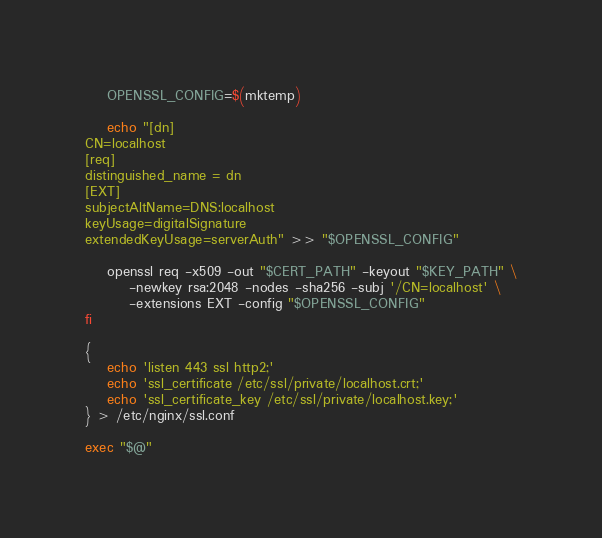<code> <loc_0><loc_0><loc_500><loc_500><_Bash_>    OPENSSL_CONFIG=$(mktemp)

    echo "[dn]
CN=localhost
[req]
distinguished_name = dn
[EXT]
subjectAltName=DNS:localhost
keyUsage=digitalSignature
extendedKeyUsage=serverAuth" >> "$OPENSSL_CONFIG"

    openssl req -x509 -out "$CERT_PATH" -keyout "$KEY_PATH" \
        -newkey rsa:2048 -nodes -sha256 -subj '/CN=localhost' \
        -extensions EXT -config "$OPENSSL_CONFIG"
fi

{
    echo 'listen 443 ssl http2;'
    echo 'ssl_certificate /etc/ssl/private/localhost.crt;'
    echo 'ssl_certificate_key /etc/ssl/private/localhost.key;'
} > /etc/nginx/ssl.conf

exec "$@"
</code> 